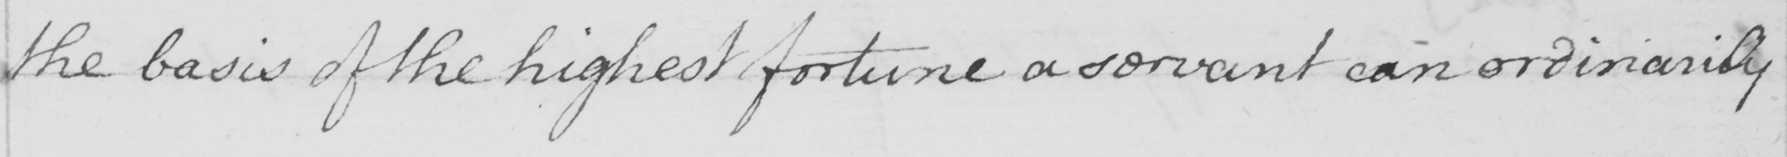Transcribe the text shown in this historical manuscript line. the basis of the highest fortune a servant can ordinarily 